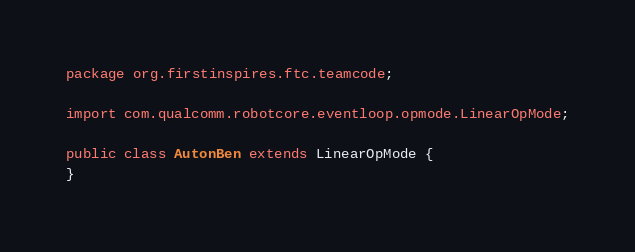<code> <loc_0><loc_0><loc_500><loc_500><_Java_>package org.firstinspires.ftc.teamcode;

import com.qualcomm.robotcore.eventloop.opmode.LinearOpMode;

public class AutonBen extends LinearOpMode {
}
</code> 